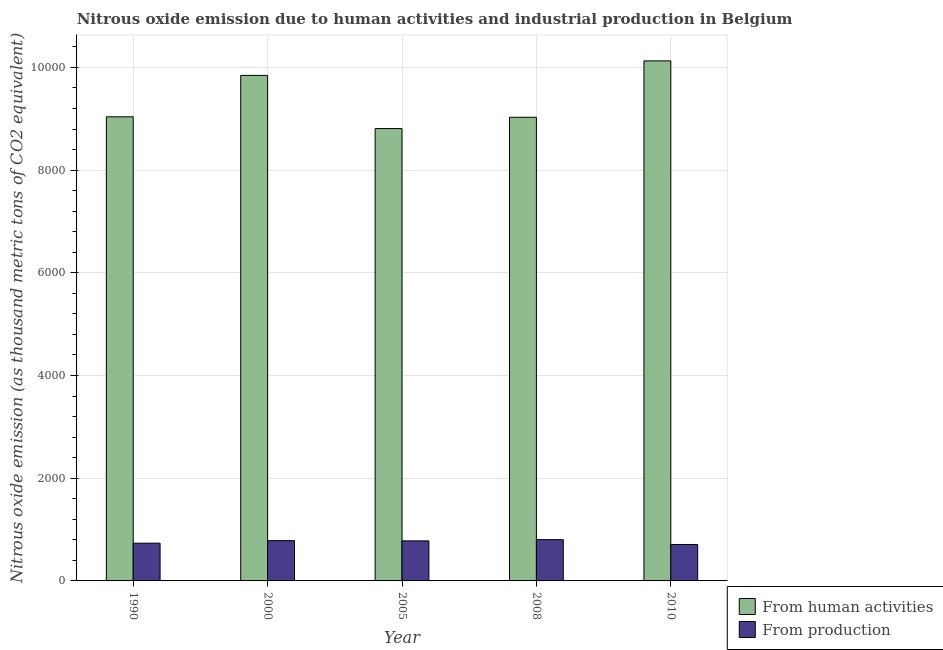How many groups of bars are there?
Provide a short and direct response. 5. Are the number of bars on each tick of the X-axis equal?
Your answer should be very brief. Yes. What is the label of the 2nd group of bars from the left?
Your answer should be compact. 2000. In how many cases, is the number of bars for a given year not equal to the number of legend labels?
Offer a terse response. 0. What is the amount of emissions generated from industries in 2008?
Your answer should be compact. 803.7. Across all years, what is the maximum amount of emissions generated from industries?
Your answer should be compact. 803.7. Across all years, what is the minimum amount of emissions from human activities?
Offer a terse response. 8808.6. In which year was the amount of emissions generated from industries maximum?
Your answer should be very brief. 2008. What is the total amount of emissions from human activities in the graph?
Give a very brief answer. 4.68e+04. What is the difference between the amount of emissions generated from industries in 2005 and that in 2010?
Offer a terse response. 70.2. What is the difference between the amount of emissions generated from industries in 1990 and the amount of emissions from human activities in 2005?
Provide a succinct answer. -44.9. What is the average amount of emissions generated from industries per year?
Offer a very short reply. 762.38. In the year 2010, what is the difference between the amount of emissions from human activities and amount of emissions generated from industries?
Provide a short and direct response. 0. What is the ratio of the amount of emissions generated from industries in 2005 to that in 2010?
Your answer should be compact. 1.1. Is the amount of emissions generated from industries in 1990 less than that in 2010?
Your response must be concise. No. Is the difference between the amount of emissions from human activities in 2000 and 2005 greater than the difference between the amount of emissions generated from industries in 2000 and 2005?
Give a very brief answer. No. What is the difference between the highest and the second highest amount of emissions generated from industries?
Your answer should be compact. 19.8. What is the difference between the highest and the lowest amount of emissions from human activities?
Give a very brief answer. 1318.2. In how many years, is the amount of emissions generated from industries greater than the average amount of emissions generated from industries taken over all years?
Provide a short and direct response. 3. What does the 2nd bar from the left in 2008 represents?
Ensure brevity in your answer.  From production. What does the 2nd bar from the right in 1990 represents?
Your answer should be very brief. From human activities. Are all the bars in the graph horizontal?
Offer a very short reply. No. What is the difference between two consecutive major ticks on the Y-axis?
Offer a very short reply. 2000. Are the values on the major ticks of Y-axis written in scientific E-notation?
Make the answer very short. No. Does the graph contain any zero values?
Provide a succinct answer. No. Where does the legend appear in the graph?
Give a very brief answer. Bottom right. How many legend labels are there?
Offer a terse response. 2. How are the legend labels stacked?
Give a very brief answer. Vertical. What is the title of the graph?
Give a very brief answer. Nitrous oxide emission due to human activities and industrial production in Belgium. Does "Public funds" appear as one of the legend labels in the graph?
Your response must be concise. No. What is the label or title of the X-axis?
Ensure brevity in your answer.  Year. What is the label or title of the Y-axis?
Keep it short and to the point. Nitrous oxide emission (as thousand metric tons of CO2 equivalent). What is the Nitrous oxide emission (as thousand metric tons of CO2 equivalent) of From human activities in 1990?
Your answer should be compact. 9037.7. What is the Nitrous oxide emission (as thousand metric tons of CO2 equivalent) in From production in 1990?
Give a very brief answer. 734.9. What is the Nitrous oxide emission (as thousand metric tons of CO2 equivalent) in From human activities in 2000?
Ensure brevity in your answer.  9844.1. What is the Nitrous oxide emission (as thousand metric tons of CO2 equivalent) of From production in 2000?
Provide a short and direct response. 783.9. What is the Nitrous oxide emission (as thousand metric tons of CO2 equivalent) in From human activities in 2005?
Ensure brevity in your answer.  8808.6. What is the Nitrous oxide emission (as thousand metric tons of CO2 equivalent) in From production in 2005?
Provide a short and direct response. 779.8. What is the Nitrous oxide emission (as thousand metric tons of CO2 equivalent) in From human activities in 2008?
Keep it short and to the point. 9028.7. What is the Nitrous oxide emission (as thousand metric tons of CO2 equivalent) of From production in 2008?
Provide a succinct answer. 803.7. What is the Nitrous oxide emission (as thousand metric tons of CO2 equivalent) in From human activities in 2010?
Give a very brief answer. 1.01e+04. What is the Nitrous oxide emission (as thousand metric tons of CO2 equivalent) of From production in 2010?
Ensure brevity in your answer.  709.6. Across all years, what is the maximum Nitrous oxide emission (as thousand metric tons of CO2 equivalent) of From human activities?
Give a very brief answer. 1.01e+04. Across all years, what is the maximum Nitrous oxide emission (as thousand metric tons of CO2 equivalent) of From production?
Make the answer very short. 803.7. Across all years, what is the minimum Nitrous oxide emission (as thousand metric tons of CO2 equivalent) in From human activities?
Your answer should be compact. 8808.6. Across all years, what is the minimum Nitrous oxide emission (as thousand metric tons of CO2 equivalent) of From production?
Your answer should be very brief. 709.6. What is the total Nitrous oxide emission (as thousand metric tons of CO2 equivalent) of From human activities in the graph?
Your response must be concise. 4.68e+04. What is the total Nitrous oxide emission (as thousand metric tons of CO2 equivalent) of From production in the graph?
Provide a short and direct response. 3811.9. What is the difference between the Nitrous oxide emission (as thousand metric tons of CO2 equivalent) of From human activities in 1990 and that in 2000?
Ensure brevity in your answer.  -806.4. What is the difference between the Nitrous oxide emission (as thousand metric tons of CO2 equivalent) in From production in 1990 and that in 2000?
Your response must be concise. -49. What is the difference between the Nitrous oxide emission (as thousand metric tons of CO2 equivalent) in From human activities in 1990 and that in 2005?
Keep it short and to the point. 229.1. What is the difference between the Nitrous oxide emission (as thousand metric tons of CO2 equivalent) in From production in 1990 and that in 2005?
Ensure brevity in your answer.  -44.9. What is the difference between the Nitrous oxide emission (as thousand metric tons of CO2 equivalent) of From human activities in 1990 and that in 2008?
Your response must be concise. 9. What is the difference between the Nitrous oxide emission (as thousand metric tons of CO2 equivalent) in From production in 1990 and that in 2008?
Provide a short and direct response. -68.8. What is the difference between the Nitrous oxide emission (as thousand metric tons of CO2 equivalent) of From human activities in 1990 and that in 2010?
Ensure brevity in your answer.  -1089.1. What is the difference between the Nitrous oxide emission (as thousand metric tons of CO2 equivalent) in From production in 1990 and that in 2010?
Offer a very short reply. 25.3. What is the difference between the Nitrous oxide emission (as thousand metric tons of CO2 equivalent) of From human activities in 2000 and that in 2005?
Keep it short and to the point. 1035.5. What is the difference between the Nitrous oxide emission (as thousand metric tons of CO2 equivalent) in From production in 2000 and that in 2005?
Your answer should be very brief. 4.1. What is the difference between the Nitrous oxide emission (as thousand metric tons of CO2 equivalent) in From human activities in 2000 and that in 2008?
Your answer should be very brief. 815.4. What is the difference between the Nitrous oxide emission (as thousand metric tons of CO2 equivalent) in From production in 2000 and that in 2008?
Your response must be concise. -19.8. What is the difference between the Nitrous oxide emission (as thousand metric tons of CO2 equivalent) of From human activities in 2000 and that in 2010?
Your response must be concise. -282.7. What is the difference between the Nitrous oxide emission (as thousand metric tons of CO2 equivalent) of From production in 2000 and that in 2010?
Offer a terse response. 74.3. What is the difference between the Nitrous oxide emission (as thousand metric tons of CO2 equivalent) in From human activities in 2005 and that in 2008?
Provide a short and direct response. -220.1. What is the difference between the Nitrous oxide emission (as thousand metric tons of CO2 equivalent) in From production in 2005 and that in 2008?
Your response must be concise. -23.9. What is the difference between the Nitrous oxide emission (as thousand metric tons of CO2 equivalent) in From human activities in 2005 and that in 2010?
Your answer should be compact. -1318.2. What is the difference between the Nitrous oxide emission (as thousand metric tons of CO2 equivalent) in From production in 2005 and that in 2010?
Your answer should be compact. 70.2. What is the difference between the Nitrous oxide emission (as thousand metric tons of CO2 equivalent) in From human activities in 2008 and that in 2010?
Your answer should be compact. -1098.1. What is the difference between the Nitrous oxide emission (as thousand metric tons of CO2 equivalent) in From production in 2008 and that in 2010?
Give a very brief answer. 94.1. What is the difference between the Nitrous oxide emission (as thousand metric tons of CO2 equivalent) in From human activities in 1990 and the Nitrous oxide emission (as thousand metric tons of CO2 equivalent) in From production in 2000?
Offer a terse response. 8253.8. What is the difference between the Nitrous oxide emission (as thousand metric tons of CO2 equivalent) in From human activities in 1990 and the Nitrous oxide emission (as thousand metric tons of CO2 equivalent) in From production in 2005?
Provide a succinct answer. 8257.9. What is the difference between the Nitrous oxide emission (as thousand metric tons of CO2 equivalent) in From human activities in 1990 and the Nitrous oxide emission (as thousand metric tons of CO2 equivalent) in From production in 2008?
Offer a terse response. 8234. What is the difference between the Nitrous oxide emission (as thousand metric tons of CO2 equivalent) in From human activities in 1990 and the Nitrous oxide emission (as thousand metric tons of CO2 equivalent) in From production in 2010?
Your answer should be very brief. 8328.1. What is the difference between the Nitrous oxide emission (as thousand metric tons of CO2 equivalent) in From human activities in 2000 and the Nitrous oxide emission (as thousand metric tons of CO2 equivalent) in From production in 2005?
Offer a very short reply. 9064.3. What is the difference between the Nitrous oxide emission (as thousand metric tons of CO2 equivalent) in From human activities in 2000 and the Nitrous oxide emission (as thousand metric tons of CO2 equivalent) in From production in 2008?
Make the answer very short. 9040.4. What is the difference between the Nitrous oxide emission (as thousand metric tons of CO2 equivalent) of From human activities in 2000 and the Nitrous oxide emission (as thousand metric tons of CO2 equivalent) of From production in 2010?
Your answer should be compact. 9134.5. What is the difference between the Nitrous oxide emission (as thousand metric tons of CO2 equivalent) in From human activities in 2005 and the Nitrous oxide emission (as thousand metric tons of CO2 equivalent) in From production in 2008?
Ensure brevity in your answer.  8004.9. What is the difference between the Nitrous oxide emission (as thousand metric tons of CO2 equivalent) of From human activities in 2005 and the Nitrous oxide emission (as thousand metric tons of CO2 equivalent) of From production in 2010?
Offer a terse response. 8099. What is the difference between the Nitrous oxide emission (as thousand metric tons of CO2 equivalent) of From human activities in 2008 and the Nitrous oxide emission (as thousand metric tons of CO2 equivalent) of From production in 2010?
Give a very brief answer. 8319.1. What is the average Nitrous oxide emission (as thousand metric tons of CO2 equivalent) of From human activities per year?
Provide a succinct answer. 9369.18. What is the average Nitrous oxide emission (as thousand metric tons of CO2 equivalent) of From production per year?
Offer a terse response. 762.38. In the year 1990, what is the difference between the Nitrous oxide emission (as thousand metric tons of CO2 equivalent) of From human activities and Nitrous oxide emission (as thousand metric tons of CO2 equivalent) of From production?
Keep it short and to the point. 8302.8. In the year 2000, what is the difference between the Nitrous oxide emission (as thousand metric tons of CO2 equivalent) of From human activities and Nitrous oxide emission (as thousand metric tons of CO2 equivalent) of From production?
Ensure brevity in your answer.  9060.2. In the year 2005, what is the difference between the Nitrous oxide emission (as thousand metric tons of CO2 equivalent) in From human activities and Nitrous oxide emission (as thousand metric tons of CO2 equivalent) in From production?
Provide a short and direct response. 8028.8. In the year 2008, what is the difference between the Nitrous oxide emission (as thousand metric tons of CO2 equivalent) of From human activities and Nitrous oxide emission (as thousand metric tons of CO2 equivalent) of From production?
Ensure brevity in your answer.  8225. In the year 2010, what is the difference between the Nitrous oxide emission (as thousand metric tons of CO2 equivalent) in From human activities and Nitrous oxide emission (as thousand metric tons of CO2 equivalent) in From production?
Provide a succinct answer. 9417.2. What is the ratio of the Nitrous oxide emission (as thousand metric tons of CO2 equivalent) in From human activities in 1990 to that in 2000?
Give a very brief answer. 0.92. What is the ratio of the Nitrous oxide emission (as thousand metric tons of CO2 equivalent) in From production in 1990 to that in 2000?
Offer a terse response. 0.94. What is the ratio of the Nitrous oxide emission (as thousand metric tons of CO2 equivalent) of From human activities in 1990 to that in 2005?
Your answer should be compact. 1.03. What is the ratio of the Nitrous oxide emission (as thousand metric tons of CO2 equivalent) of From production in 1990 to that in 2005?
Offer a terse response. 0.94. What is the ratio of the Nitrous oxide emission (as thousand metric tons of CO2 equivalent) in From human activities in 1990 to that in 2008?
Provide a short and direct response. 1. What is the ratio of the Nitrous oxide emission (as thousand metric tons of CO2 equivalent) of From production in 1990 to that in 2008?
Keep it short and to the point. 0.91. What is the ratio of the Nitrous oxide emission (as thousand metric tons of CO2 equivalent) of From human activities in 1990 to that in 2010?
Provide a short and direct response. 0.89. What is the ratio of the Nitrous oxide emission (as thousand metric tons of CO2 equivalent) in From production in 1990 to that in 2010?
Give a very brief answer. 1.04. What is the ratio of the Nitrous oxide emission (as thousand metric tons of CO2 equivalent) in From human activities in 2000 to that in 2005?
Ensure brevity in your answer.  1.12. What is the ratio of the Nitrous oxide emission (as thousand metric tons of CO2 equivalent) of From human activities in 2000 to that in 2008?
Ensure brevity in your answer.  1.09. What is the ratio of the Nitrous oxide emission (as thousand metric tons of CO2 equivalent) in From production in 2000 to that in 2008?
Keep it short and to the point. 0.98. What is the ratio of the Nitrous oxide emission (as thousand metric tons of CO2 equivalent) of From human activities in 2000 to that in 2010?
Provide a short and direct response. 0.97. What is the ratio of the Nitrous oxide emission (as thousand metric tons of CO2 equivalent) in From production in 2000 to that in 2010?
Keep it short and to the point. 1.1. What is the ratio of the Nitrous oxide emission (as thousand metric tons of CO2 equivalent) of From human activities in 2005 to that in 2008?
Your answer should be very brief. 0.98. What is the ratio of the Nitrous oxide emission (as thousand metric tons of CO2 equivalent) in From production in 2005 to that in 2008?
Your answer should be very brief. 0.97. What is the ratio of the Nitrous oxide emission (as thousand metric tons of CO2 equivalent) of From human activities in 2005 to that in 2010?
Offer a very short reply. 0.87. What is the ratio of the Nitrous oxide emission (as thousand metric tons of CO2 equivalent) in From production in 2005 to that in 2010?
Give a very brief answer. 1.1. What is the ratio of the Nitrous oxide emission (as thousand metric tons of CO2 equivalent) in From human activities in 2008 to that in 2010?
Provide a short and direct response. 0.89. What is the ratio of the Nitrous oxide emission (as thousand metric tons of CO2 equivalent) of From production in 2008 to that in 2010?
Provide a short and direct response. 1.13. What is the difference between the highest and the second highest Nitrous oxide emission (as thousand metric tons of CO2 equivalent) of From human activities?
Offer a terse response. 282.7. What is the difference between the highest and the second highest Nitrous oxide emission (as thousand metric tons of CO2 equivalent) of From production?
Your answer should be compact. 19.8. What is the difference between the highest and the lowest Nitrous oxide emission (as thousand metric tons of CO2 equivalent) in From human activities?
Offer a terse response. 1318.2. What is the difference between the highest and the lowest Nitrous oxide emission (as thousand metric tons of CO2 equivalent) of From production?
Offer a terse response. 94.1. 